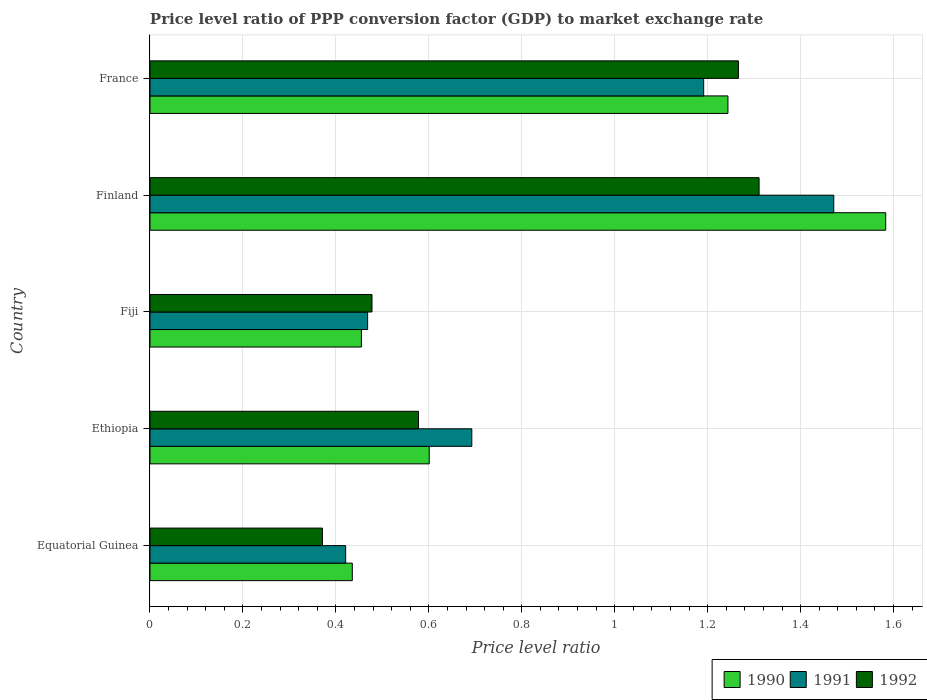How many different coloured bars are there?
Your answer should be compact. 3. How many groups of bars are there?
Your response must be concise. 5. How many bars are there on the 4th tick from the bottom?
Provide a short and direct response. 3. What is the price level ratio in 1990 in Ethiopia?
Ensure brevity in your answer.  0.6. Across all countries, what is the maximum price level ratio in 1991?
Your response must be concise. 1.47. Across all countries, what is the minimum price level ratio in 1992?
Your answer should be compact. 0.37. In which country was the price level ratio in 1991 minimum?
Your answer should be very brief. Equatorial Guinea. What is the total price level ratio in 1990 in the graph?
Offer a very short reply. 4.32. What is the difference between the price level ratio in 1992 in Ethiopia and that in Finland?
Your answer should be very brief. -0.73. What is the difference between the price level ratio in 1992 in Equatorial Guinea and the price level ratio in 1991 in Fiji?
Your answer should be very brief. -0.1. What is the average price level ratio in 1992 per country?
Keep it short and to the point. 0.8. What is the difference between the price level ratio in 1991 and price level ratio in 1990 in France?
Make the answer very short. -0.05. What is the ratio of the price level ratio in 1990 in Fiji to that in Finland?
Give a very brief answer. 0.29. What is the difference between the highest and the second highest price level ratio in 1990?
Keep it short and to the point. 0.34. What is the difference between the highest and the lowest price level ratio in 1992?
Ensure brevity in your answer.  0.94. Is the sum of the price level ratio in 1992 in Equatorial Guinea and Ethiopia greater than the maximum price level ratio in 1990 across all countries?
Make the answer very short. No. What does the 2nd bar from the top in Ethiopia represents?
Ensure brevity in your answer.  1991. Is it the case that in every country, the sum of the price level ratio in 1990 and price level ratio in 1992 is greater than the price level ratio in 1991?
Make the answer very short. Yes. How many bars are there?
Offer a terse response. 15. How many countries are there in the graph?
Your response must be concise. 5. What is the difference between two consecutive major ticks on the X-axis?
Provide a succinct answer. 0.2. Are the values on the major ticks of X-axis written in scientific E-notation?
Offer a terse response. No. Does the graph contain any zero values?
Provide a succinct answer. No. Does the graph contain grids?
Keep it short and to the point. Yes. What is the title of the graph?
Offer a very short reply. Price level ratio of PPP conversion factor (GDP) to market exchange rate. Does "2002" appear as one of the legend labels in the graph?
Give a very brief answer. No. What is the label or title of the X-axis?
Your response must be concise. Price level ratio. What is the label or title of the Y-axis?
Your answer should be compact. Country. What is the Price level ratio of 1990 in Equatorial Guinea?
Provide a short and direct response. 0.44. What is the Price level ratio in 1991 in Equatorial Guinea?
Offer a terse response. 0.42. What is the Price level ratio in 1992 in Equatorial Guinea?
Ensure brevity in your answer.  0.37. What is the Price level ratio in 1990 in Ethiopia?
Ensure brevity in your answer.  0.6. What is the Price level ratio of 1991 in Ethiopia?
Provide a succinct answer. 0.69. What is the Price level ratio in 1992 in Ethiopia?
Make the answer very short. 0.58. What is the Price level ratio in 1990 in Fiji?
Make the answer very short. 0.45. What is the Price level ratio in 1991 in Fiji?
Your answer should be compact. 0.47. What is the Price level ratio of 1992 in Fiji?
Ensure brevity in your answer.  0.48. What is the Price level ratio of 1990 in Finland?
Ensure brevity in your answer.  1.58. What is the Price level ratio in 1991 in Finland?
Provide a short and direct response. 1.47. What is the Price level ratio of 1992 in Finland?
Your answer should be very brief. 1.31. What is the Price level ratio in 1990 in France?
Offer a very short reply. 1.24. What is the Price level ratio of 1991 in France?
Your answer should be compact. 1.19. What is the Price level ratio of 1992 in France?
Your answer should be very brief. 1.27. Across all countries, what is the maximum Price level ratio of 1990?
Offer a terse response. 1.58. Across all countries, what is the maximum Price level ratio in 1991?
Offer a very short reply. 1.47. Across all countries, what is the maximum Price level ratio in 1992?
Ensure brevity in your answer.  1.31. Across all countries, what is the minimum Price level ratio in 1990?
Keep it short and to the point. 0.44. Across all countries, what is the minimum Price level ratio of 1991?
Your answer should be compact. 0.42. Across all countries, what is the minimum Price level ratio in 1992?
Your response must be concise. 0.37. What is the total Price level ratio in 1990 in the graph?
Offer a very short reply. 4.32. What is the total Price level ratio in 1991 in the graph?
Give a very brief answer. 4.24. What is the total Price level ratio in 1992 in the graph?
Your answer should be very brief. 4. What is the difference between the Price level ratio in 1990 in Equatorial Guinea and that in Ethiopia?
Give a very brief answer. -0.17. What is the difference between the Price level ratio in 1991 in Equatorial Guinea and that in Ethiopia?
Offer a very short reply. -0.27. What is the difference between the Price level ratio of 1992 in Equatorial Guinea and that in Ethiopia?
Your response must be concise. -0.21. What is the difference between the Price level ratio of 1990 in Equatorial Guinea and that in Fiji?
Offer a very short reply. -0.02. What is the difference between the Price level ratio in 1991 in Equatorial Guinea and that in Fiji?
Make the answer very short. -0.05. What is the difference between the Price level ratio in 1992 in Equatorial Guinea and that in Fiji?
Your response must be concise. -0.11. What is the difference between the Price level ratio in 1990 in Equatorial Guinea and that in Finland?
Your answer should be very brief. -1.15. What is the difference between the Price level ratio in 1991 in Equatorial Guinea and that in Finland?
Offer a terse response. -1.05. What is the difference between the Price level ratio in 1992 in Equatorial Guinea and that in Finland?
Provide a short and direct response. -0.94. What is the difference between the Price level ratio in 1990 in Equatorial Guinea and that in France?
Provide a short and direct response. -0.81. What is the difference between the Price level ratio in 1991 in Equatorial Guinea and that in France?
Your answer should be very brief. -0.77. What is the difference between the Price level ratio in 1992 in Equatorial Guinea and that in France?
Provide a succinct answer. -0.9. What is the difference between the Price level ratio of 1990 in Ethiopia and that in Fiji?
Provide a short and direct response. 0.15. What is the difference between the Price level ratio of 1991 in Ethiopia and that in Fiji?
Keep it short and to the point. 0.22. What is the difference between the Price level ratio of 1992 in Ethiopia and that in Fiji?
Provide a short and direct response. 0.1. What is the difference between the Price level ratio of 1990 in Ethiopia and that in Finland?
Offer a terse response. -0.98. What is the difference between the Price level ratio of 1991 in Ethiopia and that in Finland?
Provide a short and direct response. -0.78. What is the difference between the Price level ratio in 1992 in Ethiopia and that in Finland?
Give a very brief answer. -0.73. What is the difference between the Price level ratio of 1990 in Ethiopia and that in France?
Ensure brevity in your answer.  -0.64. What is the difference between the Price level ratio of 1991 in Ethiopia and that in France?
Provide a succinct answer. -0.5. What is the difference between the Price level ratio of 1992 in Ethiopia and that in France?
Ensure brevity in your answer.  -0.69. What is the difference between the Price level ratio of 1990 in Fiji and that in Finland?
Ensure brevity in your answer.  -1.13. What is the difference between the Price level ratio of 1991 in Fiji and that in Finland?
Provide a succinct answer. -1. What is the difference between the Price level ratio in 1992 in Fiji and that in Finland?
Your answer should be compact. -0.83. What is the difference between the Price level ratio of 1990 in Fiji and that in France?
Make the answer very short. -0.79. What is the difference between the Price level ratio in 1991 in Fiji and that in France?
Make the answer very short. -0.72. What is the difference between the Price level ratio in 1992 in Fiji and that in France?
Your response must be concise. -0.79. What is the difference between the Price level ratio of 1990 in Finland and that in France?
Keep it short and to the point. 0.34. What is the difference between the Price level ratio of 1991 in Finland and that in France?
Provide a short and direct response. 0.28. What is the difference between the Price level ratio of 1992 in Finland and that in France?
Provide a short and direct response. 0.04. What is the difference between the Price level ratio in 1990 in Equatorial Guinea and the Price level ratio in 1991 in Ethiopia?
Offer a very short reply. -0.26. What is the difference between the Price level ratio of 1990 in Equatorial Guinea and the Price level ratio of 1992 in Ethiopia?
Your answer should be very brief. -0.14. What is the difference between the Price level ratio of 1991 in Equatorial Guinea and the Price level ratio of 1992 in Ethiopia?
Your response must be concise. -0.16. What is the difference between the Price level ratio of 1990 in Equatorial Guinea and the Price level ratio of 1991 in Fiji?
Provide a succinct answer. -0.03. What is the difference between the Price level ratio of 1990 in Equatorial Guinea and the Price level ratio of 1992 in Fiji?
Your answer should be compact. -0.04. What is the difference between the Price level ratio of 1991 in Equatorial Guinea and the Price level ratio of 1992 in Fiji?
Offer a terse response. -0.06. What is the difference between the Price level ratio of 1990 in Equatorial Guinea and the Price level ratio of 1991 in Finland?
Offer a very short reply. -1.04. What is the difference between the Price level ratio of 1990 in Equatorial Guinea and the Price level ratio of 1992 in Finland?
Provide a succinct answer. -0.88. What is the difference between the Price level ratio of 1991 in Equatorial Guinea and the Price level ratio of 1992 in Finland?
Provide a succinct answer. -0.89. What is the difference between the Price level ratio in 1990 in Equatorial Guinea and the Price level ratio in 1991 in France?
Make the answer very short. -0.76. What is the difference between the Price level ratio of 1990 in Equatorial Guinea and the Price level ratio of 1992 in France?
Provide a short and direct response. -0.83. What is the difference between the Price level ratio of 1991 in Equatorial Guinea and the Price level ratio of 1992 in France?
Your answer should be very brief. -0.85. What is the difference between the Price level ratio of 1990 in Ethiopia and the Price level ratio of 1991 in Fiji?
Your answer should be compact. 0.13. What is the difference between the Price level ratio of 1990 in Ethiopia and the Price level ratio of 1992 in Fiji?
Ensure brevity in your answer.  0.12. What is the difference between the Price level ratio in 1991 in Ethiopia and the Price level ratio in 1992 in Fiji?
Your response must be concise. 0.21. What is the difference between the Price level ratio of 1990 in Ethiopia and the Price level ratio of 1991 in Finland?
Make the answer very short. -0.87. What is the difference between the Price level ratio in 1990 in Ethiopia and the Price level ratio in 1992 in Finland?
Keep it short and to the point. -0.71. What is the difference between the Price level ratio of 1991 in Ethiopia and the Price level ratio of 1992 in Finland?
Your response must be concise. -0.62. What is the difference between the Price level ratio in 1990 in Ethiopia and the Price level ratio in 1991 in France?
Ensure brevity in your answer.  -0.59. What is the difference between the Price level ratio in 1990 in Ethiopia and the Price level ratio in 1992 in France?
Keep it short and to the point. -0.67. What is the difference between the Price level ratio in 1991 in Ethiopia and the Price level ratio in 1992 in France?
Your response must be concise. -0.57. What is the difference between the Price level ratio in 1990 in Fiji and the Price level ratio in 1991 in Finland?
Your answer should be very brief. -1.02. What is the difference between the Price level ratio of 1990 in Fiji and the Price level ratio of 1992 in Finland?
Provide a short and direct response. -0.86. What is the difference between the Price level ratio in 1991 in Fiji and the Price level ratio in 1992 in Finland?
Offer a terse response. -0.84. What is the difference between the Price level ratio of 1990 in Fiji and the Price level ratio of 1991 in France?
Keep it short and to the point. -0.74. What is the difference between the Price level ratio in 1990 in Fiji and the Price level ratio in 1992 in France?
Offer a very short reply. -0.81. What is the difference between the Price level ratio in 1991 in Fiji and the Price level ratio in 1992 in France?
Provide a succinct answer. -0.8. What is the difference between the Price level ratio in 1990 in Finland and the Price level ratio in 1991 in France?
Ensure brevity in your answer.  0.39. What is the difference between the Price level ratio of 1990 in Finland and the Price level ratio of 1992 in France?
Ensure brevity in your answer.  0.32. What is the difference between the Price level ratio of 1991 in Finland and the Price level ratio of 1992 in France?
Give a very brief answer. 0.21. What is the average Price level ratio in 1990 per country?
Make the answer very short. 0.86. What is the average Price level ratio in 1991 per country?
Offer a very short reply. 0.85. What is the average Price level ratio in 1992 per country?
Keep it short and to the point. 0.8. What is the difference between the Price level ratio in 1990 and Price level ratio in 1991 in Equatorial Guinea?
Make the answer very short. 0.01. What is the difference between the Price level ratio in 1990 and Price level ratio in 1992 in Equatorial Guinea?
Your answer should be compact. 0.06. What is the difference between the Price level ratio in 1990 and Price level ratio in 1991 in Ethiopia?
Your response must be concise. -0.09. What is the difference between the Price level ratio in 1990 and Price level ratio in 1992 in Ethiopia?
Offer a very short reply. 0.02. What is the difference between the Price level ratio of 1991 and Price level ratio of 1992 in Ethiopia?
Keep it short and to the point. 0.11. What is the difference between the Price level ratio in 1990 and Price level ratio in 1991 in Fiji?
Provide a succinct answer. -0.01. What is the difference between the Price level ratio in 1990 and Price level ratio in 1992 in Fiji?
Your response must be concise. -0.02. What is the difference between the Price level ratio in 1991 and Price level ratio in 1992 in Fiji?
Provide a short and direct response. -0.01. What is the difference between the Price level ratio of 1990 and Price level ratio of 1991 in Finland?
Your answer should be compact. 0.11. What is the difference between the Price level ratio of 1990 and Price level ratio of 1992 in Finland?
Keep it short and to the point. 0.27. What is the difference between the Price level ratio of 1991 and Price level ratio of 1992 in Finland?
Your response must be concise. 0.16. What is the difference between the Price level ratio in 1990 and Price level ratio in 1991 in France?
Your response must be concise. 0.05. What is the difference between the Price level ratio in 1990 and Price level ratio in 1992 in France?
Your answer should be compact. -0.02. What is the difference between the Price level ratio of 1991 and Price level ratio of 1992 in France?
Provide a succinct answer. -0.07. What is the ratio of the Price level ratio in 1990 in Equatorial Guinea to that in Ethiopia?
Ensure brevity in your answer.  0.72. What is the ratio of the Price level ratio in 1991 in Equatorial Guinea to that in Ethiopia?
Provide a short and direct response. 0.61. What is the ratio of the Price level ratio of 1992 in Equatorial Guinea to that in Ethiopia?
Provide a succinct answer. 0.64. What is the ratio of the Price level ratio of 1990 in Equatorial Guinea to that in Fiji?
Your response must be concise. 0.96. What is the ratio of the Price level ratio in 1991 in Equatorial Guinea to that in Fiji?
Keep it short and to the point. 0.9. What is the ratio of the Price level ratio in 1992 in Equatorial Guinea to that in Fiji?
Your answer should be very brief. 0.78. What is the ratio of the Price level ratio in 1990 in Equatorial Guinea to that in Finland?
Keep it short and to the point. 0.28. What is the ratio of the Price level ratio in 1991 in Equatorial Guinea to that in Finland?
Offer a very short reply. 0.29. What is the ratio of the Price level ratio in 1992 in Equatorial Guinea to that in Finland?
Provide a succinct answer. 0.28. What is the ratio of the Price level ratio in 1991 in Equatorial Guinea to that in France?
Ensure brevity in your answer.  0.35. What is the ratio of the Price level ratio of 1992 in Equatorial Guinea to that in France?
Give a very brief answer. 0.29. What is the ratio of the Price level ratio of 1990 in Ethiopia to that in Fiji?
Offer a terse response. 1.32. What is the ratio of the Price level ratio of 1991 in Ethiopia to that in Fiji?
Ensure brevity in your answer.  1.48. What is the ratio of the Price level ratio of 1992 in Ethiopia to that in Fiji?
Your response must be concise. 1.21. What is the ratio of the Price level ratio in 1990 in Ethiopia to that in Finland?
Offer a terse response. 0.38. What is the ratio of the Price level ratio in 1991 in Ethiopia to that in Finland?
Make the answer very short. 0.47. What is the ratio of the Price level ratio in 1992 in Ethiopia to that in Finland?
Provide a short and direct response. 0.44. What is the ratio of the Price level ratio in 1990 in Ethiopia to that in France?
Offer a terse response. 0.48. What is the ratio of the Price level ratio of 1991 in Ethiopia to that in France?
Keep it short and to the point. 0.58. What is the ratio of the Price level ratio in 1992 in Ethiopia to that in France?
Keep it short and to the point. 0.46. What is the ratio of the Price level ratio of 1990 in Fiji to that in Finland?
Your answer should be compact. 0.29. What is the ratio of the Price level ratio in 1991 in Fiji to that in Finland?
Your answer should be very brief. 0.32. What is the ratio of the Price level ratio of 1992 in Fiji to that in Finland?
Keep it short and to the point. 0.36. What is the ratio of the Price level ratio in 1990 in Fiji to that in France?
Keep it short and to the point. 0.37. What is the ratio of the Price level ratio in 1991 in Fiji to that in France?
Make the answer very short. 0.39. What is the ratio of the Price level ratio in 1992 in Fiji to that in France?
Your answer should be compact. 0.38. What is the ratio of the Price level ratio of 1990 in Finland to that in France?
Make the answer very short. 1.27. What is the ratio of the Price level ratio of 1991 in Finland to that in France?
Keep it short and to the point. 1.23. What is the ratio of the Price level ratio of 1992 in Finland to that in France?
Ensure brevity in your answer.  1.04. What is the difference between the highest and the second highest Price level ratio of 1990?
Provide a succinct answer. 0.34. What is the difference between the highest and the second highest Price level ratio of 1991?
Your response must be concise. 0.28. What is the difference between the highest and the second highest Price level ratio in 1992?
Your answer should be compact. 0.04. What is the difference between the highest and the lowest Price level ratio in 1990?
Your response must be concise. 1.15. What is the difference between the highest and the lowest Price level ratio of 1991?
Ensure brevity in your answer.  1.05. What is the difference between the highest and the lowest Price level ratio in 1992?
Give a very brief answer. 0.94. 